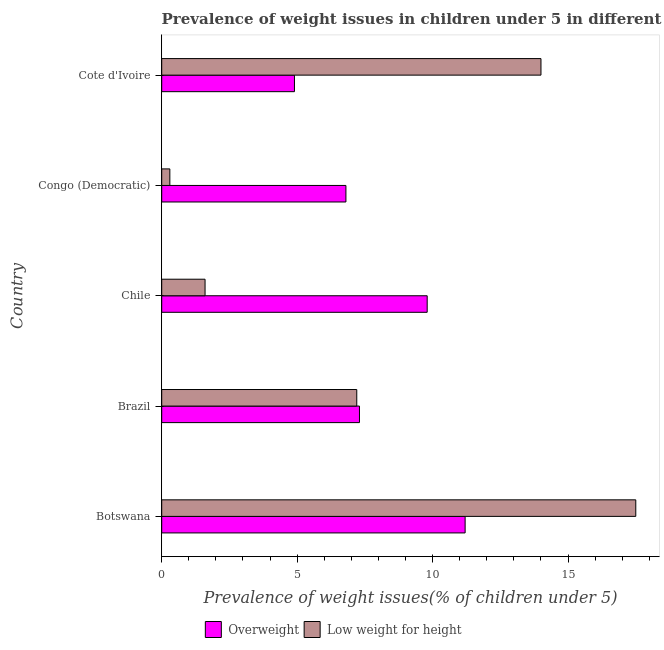What is the label of the 1st group of bars from the top?
Keep it short and to the point. Cote d'Ivoire. What is the percentage of underweight children in Congo (Democratic)?
Make the answer very short. 0.3. Across all countries, what is the maximum percentage of overweight children?
Your answer should be very brief. 11.2. Across all countries, what is the minimum percentage of underweight children?
Offer a very short reply. 0.3. In which country was the percentage of underweight children maximum?
Keep it short and to the point. Botswana. In which country was the percentage of underweight children minimum?
Make the answer very short. Congo (Democratic). What is the total percentage of underweight children in the graph?
Make the answer very short. 40.6. What is the difference between the percentage of overweight children in Brazil and the percentage of underweight children in Cote d'Ivoire?
Offer a terse response. -6.7. What is the average percentage of underweight children per country?
Provide a short and direct response. 8.12. In how many countries, is the percentage of underweight children greater than 17 %?
Your answer should be compact. 1. What is the ratio of the percentage of underweight children in Brazil to that in Cote d'Ivoire?
Your answer should be very brief. 0.51. Is the percentage of underweight children in Brazil less than that in Congo (Democratic)?
Give a very brief answer. No. Is the difference between the percentage of underweight children in Botswana and Brazil greater than the difference between the percentage of overweight children in Botswana and Brazil?
Offer a terse response. Yes. What does the 1st bar from the top in Botswana represents?
Ensure brevity in your answer.  Low weight for height. What does the 1st bar from the bottom in Botswana represents?
Keep it short and to the point. Overweight. What is the difference between two consecutive major ticks on the X-axis?
Make the answer very short. 5. Are the values on the major ticks of X-axis written in scientific E-notation?
Provide a short and direct response. No. Does the graph contain any zero values?
Make the answer very short. No. Where does the legend appear in the graph?
Your answer should be very brief. Bottom center. How many legend labels are there?
Offer a terse response. 2. How are the legend labels stacked?
Offer a terse response. Horizontal. What is the title of the graph?
Ensure brevity in your answer.  Prevalence of weight issues in children under 5 in different countries in 2007. What is the label or title of the X-axis?
Offer a very short reply. Prevalence of weight issues(% of children under 5). What is the Prevalence of weight issues(% of children under 5) in Overweight in Botswana?
Keep it short and to the point. 11.2. What is the Prevalence of weight issues(% of children under 5) of Low weight for height in Botswana?
Provide a short and direct response. 17.5. What is the Prevalence of weight issues(% of children under 5) of Overweight in Brazil?
Make the answer very short. 7.3. What is the Prevalence of weight issues(% of children under 5) in Low weight for height in Brazil?
Provide a short and direct response. 7.2. What is the Prevalence of weight issues(% of children under 5) of Overweight in Chile?
Give a very brief answer. 9.8. What is the Prevalence of weight issues(% of children under 5) of Low weight for height in Chile?
Keep it short and to the point. 1.6. What is the Prevalence of weight issues(% of children under 5) in Overweight in Congo (Democratic)?
Make the answer very short. 6.8. What is the Prevalence of weight issues(% of children under 5) of Low weight for height in Congo (Democratic)?
Provide a short and direct response. 0.3. What is the Prevalence of weight issues(% of children under 5) of Overweight in Cote d'Ivoire?
Your answer should be compact. 4.9. Across all countries, what is the maximum Prevalence of weight issues(% of children under 5) in Overweight?
Your answer should be very brief. 11.2. Across all countries, what is the maximum Prevalence of weight issues(% of children under 5) of Low weight for height?
Provide a short and direct response. 17.5. Across all countries, what is the minimum Prevalence of weight issues(% of children under 5) in Overweight?
Your answer should be very brief. 4.9. Across all countries, what is the minimum Prevalence of weight issues(% of children under 5) in Low weight for height?
Provide a short and direct response. 0.3. What is the total Prevalence of weight issues(% of children under 5) in Overweight in the graph?
Offer a very short reply. 40. What is the total Prevalence of weight issues(% of children under 5) of Low weight for height in the graph?
Your answer should be very brief. 40.6. What is the difference between the Prevalence of weight issues(% of children under 5) of Overweight in Botswana and that in Chile?
Your answer should be very brief. 1.4. What is the difference between the Prevalence of weight issues(% of children under 5) in Low weight for height in Botswana and that in Chile?
Give a very brief answer. 15.9. What is the difference between the Prevalence of weight issues(% of children under 5) in Overweight in Botswana and that in Congo (Democratic)?
Offer a terse response. 4.4. What is the difference between the Prevalence of weight issues(% of children under 5) of Low weight for height in Botswana and that in Congo (Democratic)?
Your answer should be compact. 17.2. What is the difference between the Prevalence of weight issues(% of children under 5) of Low weight for height in Botswana and that in Cote d'Ivoire?
Offer a very short reply. 3.5. What is the difference between the Prevalence of weight issues(% of children under 5) in Overweight in Brazil and that in Chile?
Ensure brevity in your answer.  -2.5. What is the difference between the Prevalence of weight issues(% of children under 5) of Low weight for height in Brazil and that in Congo (Democratic)?
Offer a terse response. 6.9. What is the difference between the Prevalence of weight issues(% of children under 5) of Overweight in Chile and that in Cote d'Ivoire?
Your answer should be very brief. 4.9. What is the difference between the Prevalence of weight issues(% of children under 5) in Overweight in Congo (Democratic) and that in Cote d'Ivoire?
Offer a terse response. 1.9. What is the difference between the Prevalence of weight issues(% of children under 5) in Low weight for height in Congo (Democratic) and that in Cote d'Ivoire?
Offer a very short reply. -13.7. What is the difference between the Prevalence of weight issues(% of children under 5) in Overweight in Botswana and the Prevalence of weight issues(% of children under 5) in Low weight for height in Congo (Democratic)?
Your response must be concise. 10.9. What is the difference between the Prevalence of weight issues(% of children under 5) in Overweight in Brazil and the Prevalence of weight issues(% of children under 5) in Low weight for height in Congo (Democratic)?
Keep it short and to the point. 7. What is the difference between the Prevalence of weight issues(% of children under 5) in Overweight in Chile and the Prevalence of weight issues(% of children under 5) in Low weight for height in Congo (Democratic)?
Offer a very short reply. 9.5. What is the average Prevalence of weight issues(% of children under 5) in Overweight per country?
Keep it short and to the point. 8. What is the average Prevalence of weight issues(% of children under 5) of Low weight for height per country?
Provide a short and direct response. 8.12. What is the difference between the Prevalence of weight issues(% of children under 5) in Overweight and Prevalence of weight issues(% of children under 5) in Low weight for height in Botswana?
Provide a succinct answer. -6.3. What is the difference between the Prevalence of weight issues(% of children under 5) of Overweight and Prevalence of weight issues(% of children under 5) of Low weight for height in Brazil?
Your response must be concise. 0.1. What is the difference between the Prevalence of weight issues(% of children under 5) in Overweight and Prevalence of weight issues(% of children under 5) in Low weight for height in Cote d'Ivoire?
Offer a terse response. -9.1. What is the ratio of the Prevalence of weight issues(% of children under 5) in Overweight in Botswana to that in Brazil?
Your answer should be very brief. 1.53. What is the ratio of the Prevalence of weight issues(% of children under 5) in Low weight for height in Botswana to that in Brazil?
Offer a very short reply. 2.43. What is the ratio of the Prevalence of weight issues(% of children under 5) of Low weight for height in Botswana to that in Chile?
Ensure brevity in your answer.  10.94. What is the ratio of the Prevalence of weight issues(% of children under 5) in Overweight in Botswana to that in Congo (Democratic)?
Keep it short and to the point. 1.65. What is the ratio of the Prevalence of weight issues(% of children under 5) of Low weight for height in Botswana to that in Congo (Democratic)?
Your response must be concise. 58.33. What is the ratio of the Prevalence of weight issues(% of children under 5) of Overweight in Botswana to that in Cote d'Ivoire?
Ensure brevity in your answer.  2.29. What is the ratio of the Prevalence of weight issues(% of children under 5) of Overweight in Brazil to that in Chile?
Your response must be concise. 0.74. What is the ratio of the Prevalence of weight issues(% of children under 5) in Low weight for height in Brazil to that in Chile?
Ensure brevity in your answer.  4.5. What is the ratio of the Prevalence of weight issues(% of children under 5) of Overweight in Brazil to that in Congo (Democratic)?
Keep it short and to the point. 1.07. What is the ratio of the Prevalence of weight issues(% of children under 5) in Low weight for height in Brazil to that in Congo (Democratic)?
Provide a succinct answer. 24. What is the ratio of the Prevalence of weight issues(% of children under 5) in Overweight in Brazil to that in Cote d'Ivoire?
Your answer should be very brief. 1.49. What is the ratio of the Prevalence of weight issues(% of children under 5) in Low weight for height in Brazil to that in Cote d'Ivoire?
Provide a short and direct response. 0.51. What is the ratio of the Prevalence of weight issues(% of children under 5) of Overweight in Chile to that in Congo (Democratic)?
Offer a terse response. 1.44. What is the ratio of the Prevalence of weight issues(% of children under 5) of Low weight for height in Chile to that in Congo (Democratic)?
Your answer should be compact. 5.33. What is the ratio of the Prevalence of weight issues(% of children under 5) in Low weight for height in Chile to that in Cote d'Ivoire?
Give a very brief answer. 0.11. What is the ratio of the Prevalence of weight issues(% of children under 5) in Overweight in Congo (Democratic) to that in Cote d'Ivoire?
Your response must be concise. 1.39. What is the ratio of the Prevalence of weight issues(% of children under 5) in Low weight for height in Congo (Democratic) to that in Cote d'Ivoire?
Keep it short and to the point. 0.02. What is the difference between the highest and the lowest Prevalence of weight issues(% of children under 5) in Low weight for height?
Offer a very short reply. 17.2. 